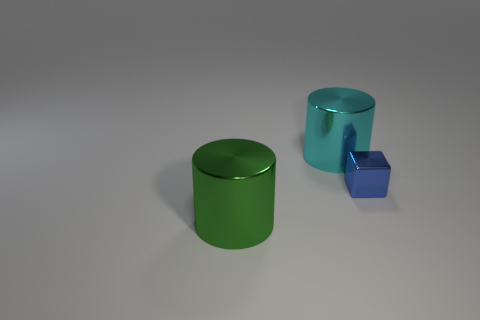Are there more large shiny things that are behind the blue object than big cylinders on the right side of the green object?
Provide a short and direct response. No. Does the metallic thing in front of the blue metallic thing have the same color as the cylinder that is behind the tiny blue object?
Make the answer very short. No. There is a cyan cylinder; are there any blue shiny blocks behind it?
Ensure brevity in your answer.  No. What is the material of the blue object?
Keep it short and to the point. Metal. What is the shape of the big shiny object in front of the small thing?
Your response must be concise. Cylinder. Is there a blue rubber cylinder of the same size as the cube?
Offer a very short reply. No. Do the cylinder that is behind the blue metal object and the large green thing have the same material?
Ensure brevity in your answer.  Yes. Are there the same number of big things behind the large green cylinder and tiny shiny cubes that are behind the blue thing?
Your answer should be very brief. No. What shape is the metallic thing that is behind the green metal thing and in front of the cyan metallic cylinder?
Your answer should be compact. Cube. How many blue objects are on the right side of the big cyan metal cylinder?
Provide a short and direct response. 1. 